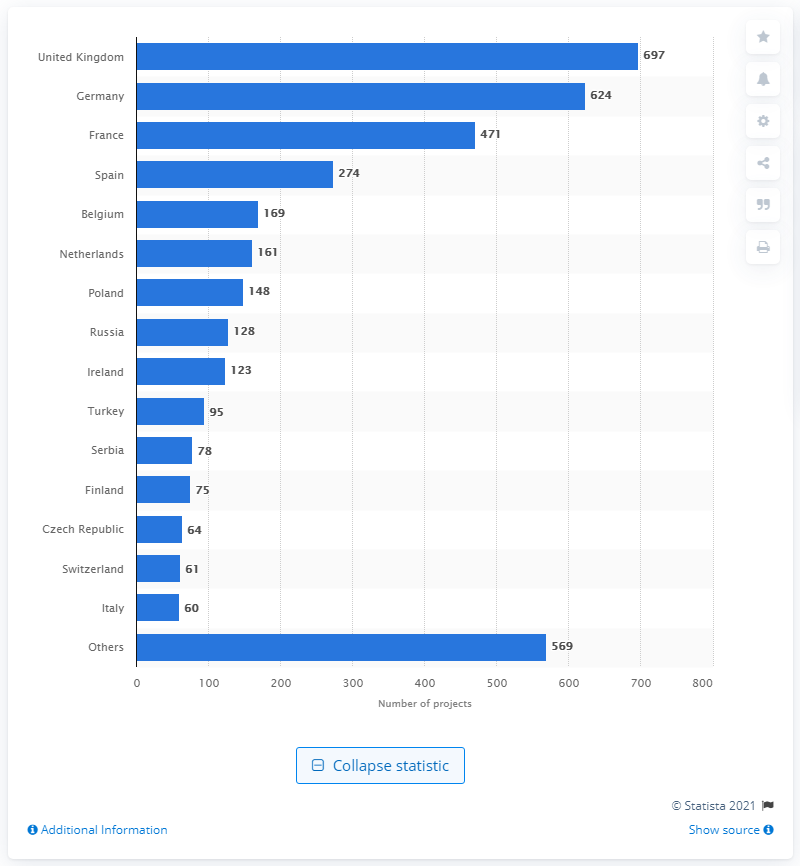List a handful of essential elements in this visual. In 2012, a total of 697 Foreign Direct Investment (FDI) projects were established in the United Kingdom. 